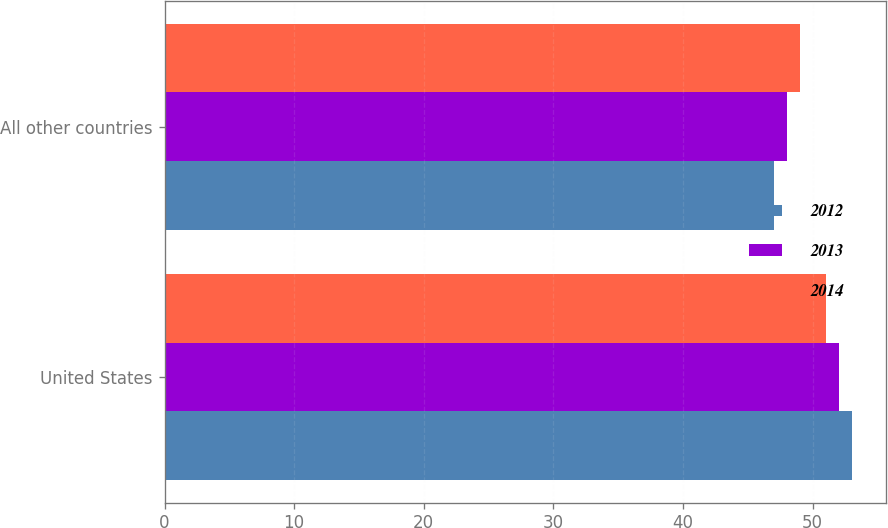Convert chart to OTSL. <chart><loc_0><loc_0><loc_500><loc_500><stacked_bar_chart><ecel><fcel>United States<fcel>All other countries<nl><fcel>2012<fcel>53<fcel>47<nl><fcel>2013<fcel>52<fcel>48<nl><fcel>2014<fcel>51<fcel>49<nl></chart> 